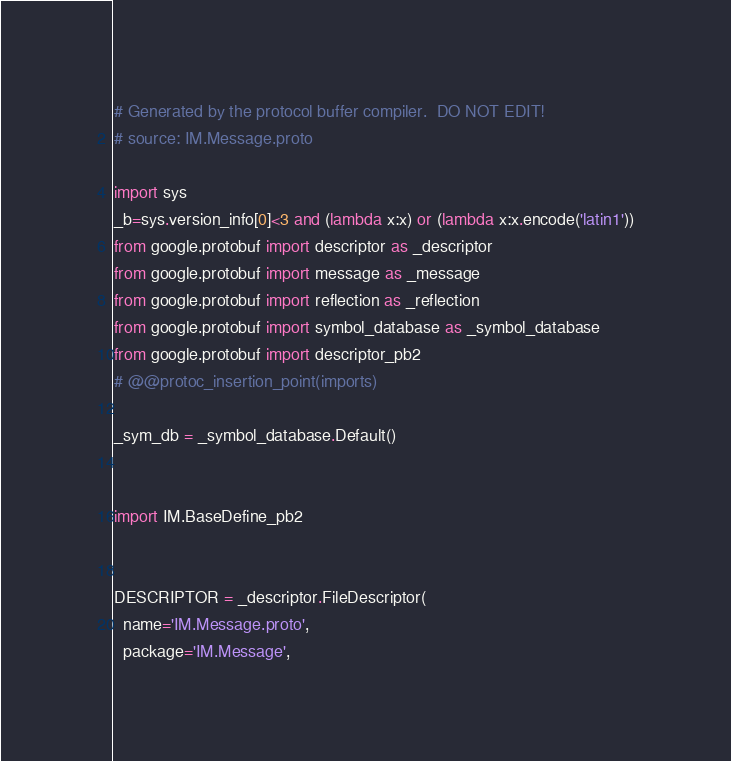<code> <loc_0><loc_0><loc_500><loc_500><_Python_># Generated by the protocol buffer compiler.  DO NOT EDIT!
# source: IM.Message.proto

import sys
_b=sys.version_info[0]<3 and (lambda x:x) or (lambda x:x.encode('latin1'))
from google.protobuf import descriptor as _descriptor
from google.protobuf import message as _message
from google.protobuf import reflection as _reflection
from google.protobuf import symbol_database as _symbol_database
from google.protobuf import descriptor_pb2
# @@protoc_insertion_point(imports)

_sym_db = _symbol_database.Default()


import IM.BaseDefine_pb2


DESCRIPTOR = _descriptor.FileDescriptor(
  name='IM.Message.proto',
  package='IM.Message',</code> 